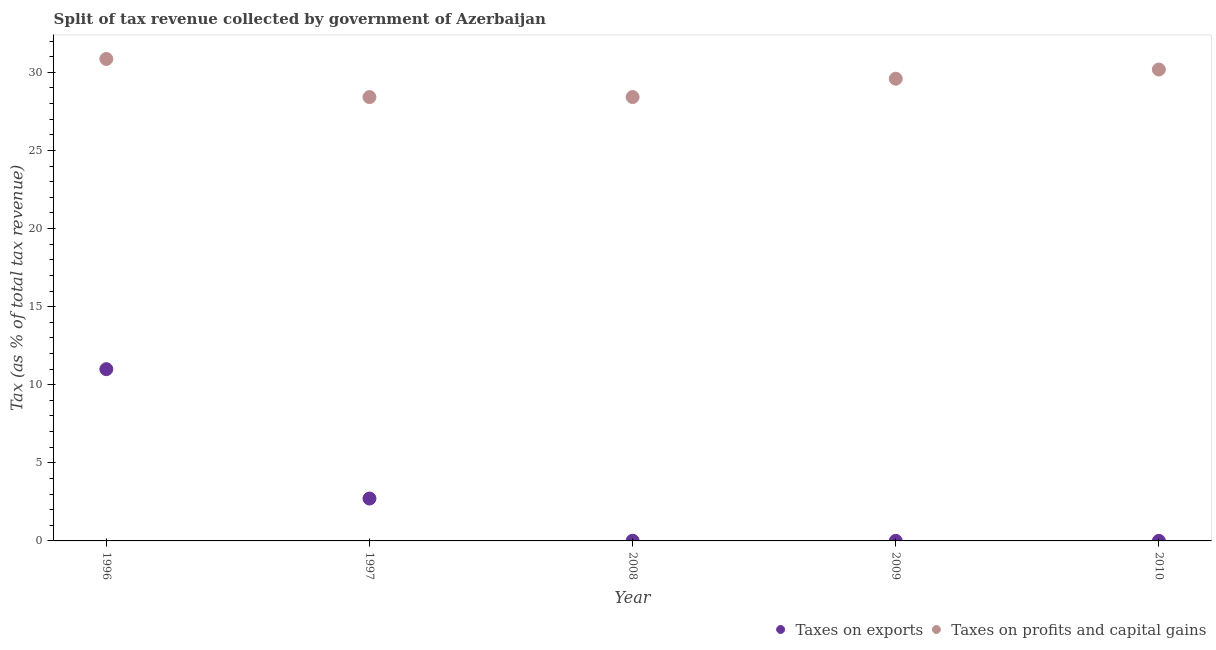What is the percentage of revenue obtained from taxes on exports in 1997?
Offer a terse response. 2.71. Across all years, what is the maximum percentage of revenue obtained from taxes on exports?
Keep it short and to the point. 11. Across all years, what is the minimum percentage of revenue obtained from taxes on exports?
Make the answer very short. 0. What is the total percentage of revenue obtained from taxes on exports in the graph?
Keep it short and to the point. 13.73. What is the difference between the percentage of revenue obtained from taxes on exports in 2008 and that in 2010?
Your answer should be very brief. 0.01. What is the difference between the percentage of revenue obtained from taxes on profits and capital gains in 1997 and the percentage of revenue obtained from taxes on exports in 2008?
Ensure brevity in your answer.  28.4. What is the average percentage of revenue obtained from taxes on profits and capital gains per year?
Offer a very short reply. 29.49. In the year 2009, what is the difference between the percentage of revenue obtained from taxes on profits and capital gains and percentage of revenue obtained from taxes on exports?
Provide a succinct answer. 29.59. What is the ratio of the percentage of revenue obtained from taxes on exports in 1996 to that in 2009?
Make the answer very short. 2761.36. What is the difference between the highest and the second highest percentage of revenue obtained from taxes on exports?
Your response must be concise. 8.28. What is the difference between the highest and the lowest percentage of revenue obtained from taxes on profits and capital gains?
Give a very brief answer. 2.44. In how many years, is the percentage of revenue obtained from taxes on exports greater than the average percentage of revenue obtained from taxes on exports taken over all years?
Your answer should be compact. 1. How many years are there in the graph?
Give a very brief answer. 5. What is the difference between two consecutive major ticks on the Y-axis?
Make the answer very short. 5. Are the values on the major ticks of Y-axis written in scientific E-notation?
Ensure brevity in your answer.  No. Does the graph contain any zero values?
Ensure brevity in your answer.  No. Where does the legend appear in the graph?
Offer a terse response. Bottom right. How are the legend labels stacked?
Offer a terse response. Horizontal. What is the title of the graph?
Give a very brief answer. Split of tax revenue collected by government of Azerbaijan. Does "Nonresident" appear as one of the legend labels in the graph?
Offer a very short reply. No. What is the label or title of the Y-axis?
Provide a short and direct response. Tax (as % of total tax revenue). What is the Tax (as % of total tax revenue) of Taxes on exports in 1996?
Provide a succinct answer. 11. What is the Tax (as % of total tax revenue) of Taxes on profits and capital gains in 1996?
Provide a short and direct response. 30.86. What is the Tax (as % of total tax revenue) in Taxes on exports in 1997?
Keep it short and to the point. 2.71. What is the Tax (as % of total tax revenue) in Taxes on profits and capital gains in 1997?
Give a very brief answer. 28.42. What is the Tax (as % of total tax revenue) of Taxes on exports in 2008?
Give a very brief answer. 0.01. What is the Tax (as % of total tax revenue) in Taxes on profits and capital gains in 2008?
Ensure brevity in your answer.  28.42. What is the Tax (as % of total tax revenue) in Taxes on exports in 2009?
Offer a very short reply. 0. What is the Tax (as % of total tax revenue) in Taxes on profits and capital gains in 2009?
Offer a very short reply. 29.59. What is the Tax (as % of total tax revenue) in Taxes on exports in 2010?
Provide a short and direct response. 0. What is the Tax (as % of total tax revenue) in Taxes on profits and capital gains in 2010?
Offer a very short reply. 30.18. Across all years, what is the maximum Tax (as % of total tax revenue) of Taxes on exports?
Make the answer very short. 11. Across all years, what is the maximum Tax (as % of total tax revenue) of Taxes on profits and capital gains?
Offer a terse response. 30.86. Across all years, what is the minimum Tax (as % of total tax revenue) of Taxes on exports?
Your answer should be very brief. 0. Across all years, what is the minimum Tax (as % of total tax revenue) in Taxes on profits and capital gains?
Keep it short and to the point. 28.42. What is the total Tax (as % of total tax revenue) in Taxes on exports in the graph?
Keep it short and to the point. 13.73. What is the total Tax (as % of total tax revenue) of Taxes on profits and capital gains in the graph?
Provide a short and direct response. 147.47. What is the difference between the Tax (as % of total tax revenue) of Taxes on exports in 1996 and that in 1997?
Your response must be concise. 8.28. What is the difference between the Tax (as % of total tax revenue) in Taxes on profits and capital gains in 1996 and that in 1997?
Ensure brevity in your answer.  2.44. What is the difference between the Tax (as % of total tax revenue) in Taxes on exports in 1996 and that in 2008?
Provide a succinct answer. 10.98. What is the difference between the Tax (as % of total tax revenue) of Taxes on profits and capital gains in 1996 and that in 2008?
Make the answer very short. 2.44. What is the difference between the Tax (as % of total tax revenue) in Taxes on exports in 1996 and that in 2009?
Provide a short and direct response. 10.99. What is the difference between the Tax (as % of total tax revenue) in Taxes on profits and capital gains in 1996 and that in 2009?
Provide a short and direct response. 1.26. What is the difference between the Tax (as % of total tax revenue) of Taxes on exports in 1996 and that in 2010?
Provide a short and direct response. 10.99. What is the difference between the Tax (as % of total tax revenue) of Taxes on profits and capital gains in 1996 and that in 2010?
Make the answer very short. 0.68. What is the difference between the Tax (as % of total tax revenue) of Taxes on exports in 1997 and that in 2008?
Provide a succinct answer. 2.7. What is the difference between the Tax (as % of total tax revenue) in Taxes on profits and capital gains in 1997 and that in 2008?
Your answer should be very brief. -0. What is the difference between the Tax (as % of total tax revenue) of Taxes on exports in 1997 and that in 2009?
Your answer should be compact. 2.71. What is the difference between the Tax (as % of total tax revenue) in Taxes on profits and capital gains in 1997 and that in 2009?
Your answer should be very brief. -1.18. What is the difference between the Tax (as % of total tax revenue) in Taxes on exports in 1997 and that in 2010?
Your answer should be compact. 2.71. What is the difference between the Tax (as % of total tax revenue) of Taxes on profits and capital gains in 1997 and that in 2010?
Your answer should be very brief. -1.76. What is the difference between the Tax (as % of total tax revenue) of Taxes on exports in 2008 and that in 2009?
Your answer should be very brief. 0.01. What is the difference between the Tax (as % of total tax revenue) of Taxes on profits and capital gains in 2008 and that in 2009?
Provide a succinct answer. -1.17. What is the difference between the Tax (as % of total tax revenue) of Taxes on exports in 2008 and that in 2010?
Make the answer very short. 0.01. What is the difference between the Tax (as % of total tax revenue) of Taxes on profits and capital gains in 2008 and that in 2010?
Provide a succinct answer. -1.76. What is the difference between the Tax (as % of total tax revenue) of Taxes on exports in 2009 and that in 2010?
Provide a short and direct response. 0. What is the difference between the Tax (as % of total tax revenue) of Taxes on profits and capital gains in 2009 and that in 2010?
Offer a terse response. -0.59. What is the difference between the Tax (as % of total tax revenue) of Taxes on exports in 1996 and the Tax (as % of total tax revenue) of Taxes on profits and capital gains in 1997?
Make the answer very short. -17.42. What is the difference between the Tax (as % of total tax revenue) of Taxes on exports in 1996 and the Tax (as % of total tax revenue) of Taxes on profits and capital gains in 2008?
Offer a terse response. -17.42. What is the difference between the Tax (as % of total tax revenue) of Taxes on exports in 1996 and the Tax (as % of total tax revenue) of Taxes on profits and capital gains in 2009?
Your response must be concise. -18.6. What is the difference between the Tax (as % of total tax revenue) in Taxes on exports in 1996 and the Tax (as % of total tax revenue) in Taxes on profits and capital gains in 2010?
Ensure brevity in your answer.  -19.18. What is the difference between the Tax (as % of total tax revenue) of Taxes on exports in 1997 and the Tax (as % of total tax revenue) of Taxes on profits and capital gains in 2008?
Ensure brevity in your answer.  -25.7. What is the difference between the Tax (as % of total tax revenue) of Taxes on exports in 1997 and the Tax (as % of total tax revenue) of Taxes on profits and capital gains in 2009?
Your answer should be compact. -26.88. What is the difference between the Tax (as % of total tax revenue) in Taxes on exports in 1997 and the Tax (as % of total tax revenue) in Taxes on profits and capital gains in 2010?
Keep it short and to the point. -27.47. What is the difference between the Tax (as % of total tax revenue) in Taxes on exports in 2008 and the Tax (as % of total tax revenue) in Taxes on profits and capital gains in 2009?
Provide a short and direct response. -29.58. What is the difference between the Tax (as % of total tax revenue) of Taxes on exports in 2008 and the Tax (as % of total tax revenue) of Taxes on profits and capital gains in 2010?
Give a very brief answer. -30.17. What is the difference between the Tax (as % of total tax revenue) in Taxes on exports in 2009 and the Tax (as % of total tax revenue) in Taxes on profits and capital gains in 2010?
Ensure brevity in your answer.  -30.18. What is the average Tax (as % of total tax revenue) of Taxes on exports per year?
Offer a very short reply. 2.75. What is the average Tax (as % of total tax revenue) of Taxes on profits and capital gains per year?
Offer a terse response. 29.49. In the year 1996, what is the difference between the Tax (as % of total tax revenue) of Taxes on exports and Tax (as % of total tax revenue) of Taxes on profits and capital gains?
Your answer should be compact. -19.86. In the year 1997, what is the difference between the Tax (as % of total tax revenue) in Taxes on exports and Tax (as % of total tax revenue) in Taxes on profits and capital gains?
Ensure brevity in your answer.  -25.7. In the year 2008, what is the difference between the Tax (as % of total tax revenue) of Taxes on exports and Tax (as % of total tax revenue) of Taxes on profits and capital gains?
Your answer should be compact. -28.41. In the year 2009, what is the difference between the Tax (as % of total tax revenue) of Taxes on exports and Tax (as % of total tax revenue) of Taxes on profits and capital gains?
Offer a very short reply. -29.59. In the year 2010, what is the difference between the Tax (as % of total tax revenue) of Taxes on exports and Tax (as % of total tax revenue) of Taxes on profits and capital gains?
Provide a short and direct response. -30.18. What is the ratio of the Tax (as % of total tax revenue) of Taxes on exports in 1996 to that in 1997?
Make the answer very short. 4.05. What is the ratio of the Tax (as % of total tax revenue) of Taxes on profits and capital gains in 1996 to that in 1997?
Ensure brevity in your answer.  1.09. What is the ratio of the Tax (as % of total tax revenue) in Taxes on exports in 1996 to that in 2008?
Your answer should be compact. 905.98. What is the ratio of the Tax (as % of total tax revenue) in Taxes on profits and capital gains in 1996 to that in 2008?
Give a very brief answer. 1.09. What is the ratio of the Tax (as % of total tax revenue) of Taxes on exports in 1996 to that in 2009?
Provide a succinct answer. 2761.36. What is the ratio of the Tax (as % of total tax revenue) in Taxes on profits and capital gains in 1996 to that in 2009?
Offer a very short reply. 1.04. What is the ratio of the Tax (as % of total tax revenue) in Taxes on exports in 1996 to that in 2010?
Provide a short and direct response. 2838.67. What is the ratio of the Tax (as % of total tax revenue) of Taxes on profits and capital gains in 1996 to that in 2010?
Your answer should be compact. 1.02. What is the ratio of the Tax (as % of total tax revenue) in Taxes on exports in 1997 to that in 2008?
Offer a very short reply. 223.55. What is the ratio of the Tax (as % of total tax revenue) in Taxes on profits and capital gains in 1997 to that in 2008?
Keep it short and to the point. 1. What is the ratio of the Tax (as % of total tax revenue) in Taxes on exports in 1997 to that in 2009?
Keep it short and to the point. 681.37. What is the ratio of the Tax (as % of total tax revenue) of Taxes on profits and capital gains in 1997 to that in 2009?
Give a very brief answer. 0.96. What is the ratio of the Tax (as % of total tax revenue) in Taxes on exports in 1997 to that in 2010?
Provide a short and direct response. 700.44. What is the ratio of the Tax (as % of total tax revenue) in Taxes on profits and capital gains in 1997 to that in 2010?
Offer a terse response. 0.94. What is the ratio of the Tax (as % of total tax revenue) in Taxes on exports in 2008 to that in 2009?
Your response must be concise. 3.05. What is the ratio of the Tax (as % of total tax revenue) of Taxes on profits and capital gains in 2008 to that in 2009?
Provide a short and direct response. 0.96. What is the ratio of the Tax (as % of total tax revenue) in Taxes on exports in 2008 to that in 2010?
Give a very brief answer. 3.13. What is the ratio of the Tax (as % of total tax revenue) in Taxes on profits and capital gains in 2008 to that in 2010?
Offer a terse response. 0.94. What is the ratio of the Tax (as % of total tax revenue) in Taxes on exports in 2009 to that in 2010?
Your answer should be compact. 1.03. What is the ratio of the Tax (as % of total tax revenue) in Taxes on profits and capital gains in 2009 to that in 2010?
Your response must be concise. 0.98. What is the difference between the highest and the second highest Tax (as % of total tax revenue) in Taxes on exports?
Offer a terse response. 8.28. What is the difference between the highest and the second highest Tax (as % of total tax revenue) of Taxes on profits and capital gains?
Provide a succinct answer. 0.68. What is the difference between the highest and the lowest Tax (as % of total tax revenue) of Taxes on exports?
Keep it short and to the point. 10.99. What is the difference between the highest and the lowest Tax (as % of total tax revenue) of Taxes on profits and capital gains?
Give a very brief answer. 2.44. 